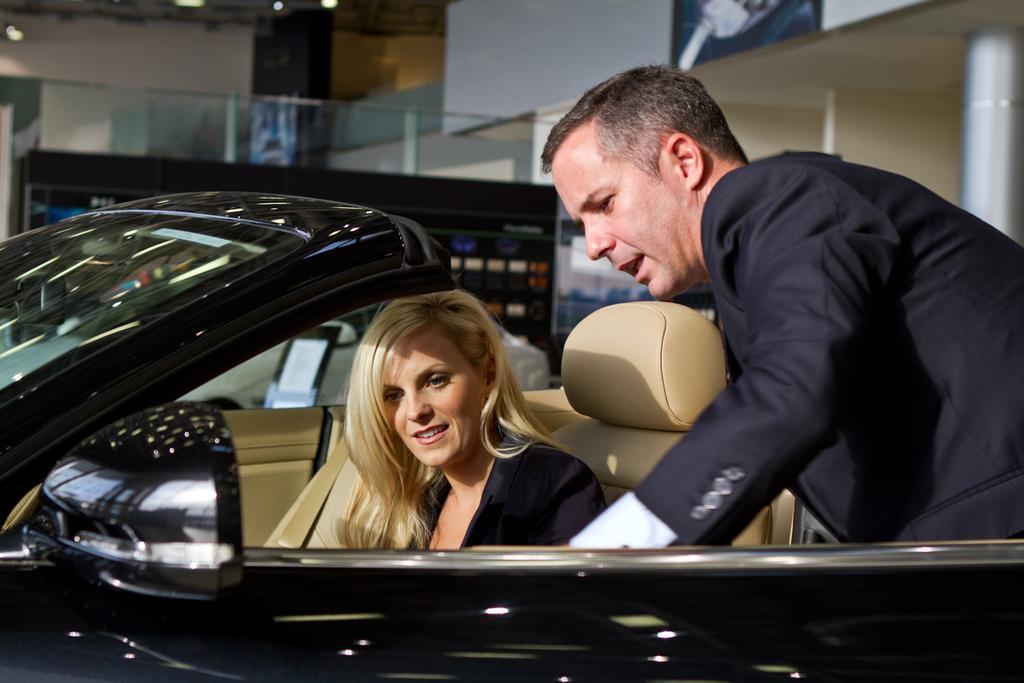Can you describe this image briefly? In this image we can see a person sitting in the car and the other person standing. At the back we can see the wall with frame and pillars. And we can see a glass and board with lights. 